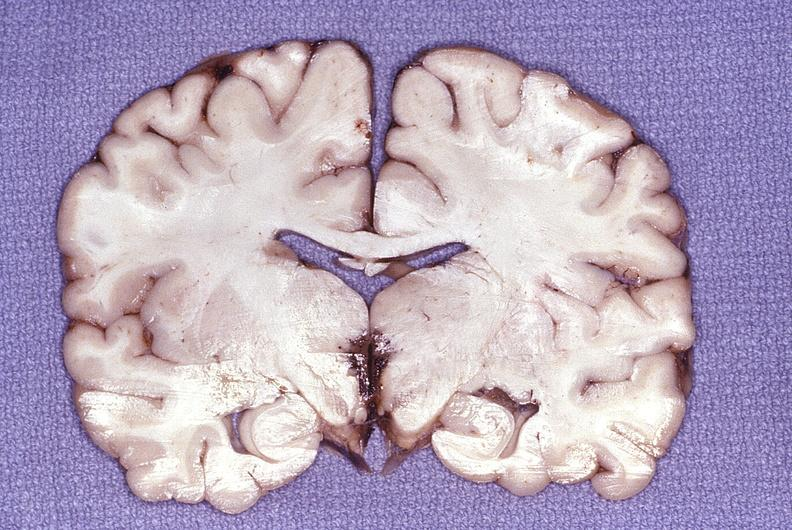s nervous present?
Answer the question using a single word or phrase. Yes 